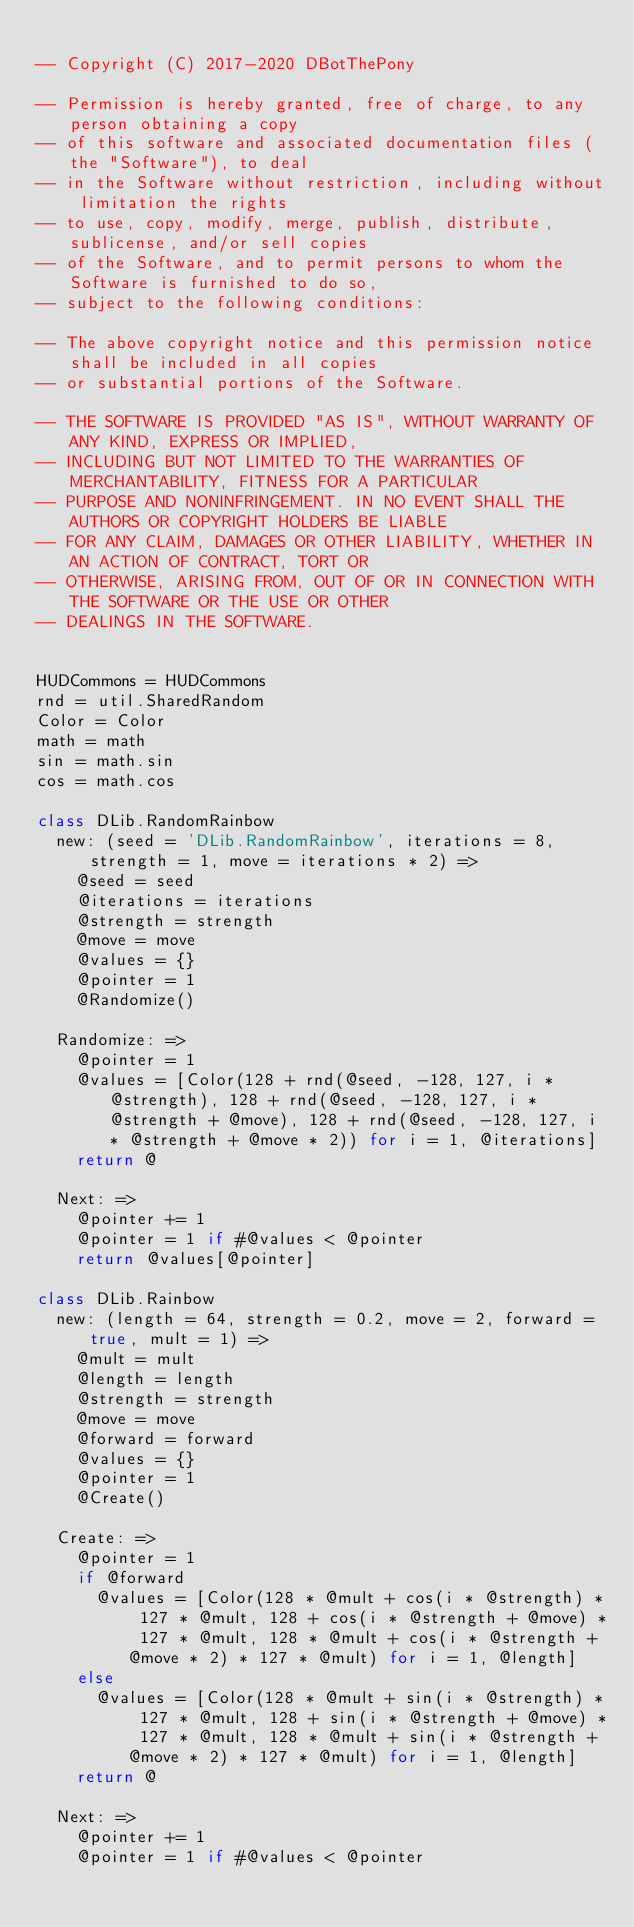<code> <loc_0><loc_0><loc_500><loc_500><_MoonScript_>
-- Copyright (C) 2017-2020 DBotThePony

-- Permission is hereby granted, free of charge, to any person obtaining a copy
-- of this software and associated documentation files (the "Software"), to deal
-- in the Software without restriction, including without limitation the rights
-- to use, copy, modify, merge, publish, distribute, sublicense, and/or sell copies
-- of the Software, and to permit persons to whom the Software is furnished to do so,
-- subject to the following conditions:

-- The above copyright notice and this permission notice shall be included in all copies
-- or substantial portions of the Software.

-- THE SOFTWARE IS PROVIDED "AS IS", WITHOUT WARRANTY OF ANY KIND, EXPRESS OR IMPLIED,
-- INCLUDING BUT NOT LIMITED TO THE WARRANTIES OF MERCHANTABILITY, FITNESS FOR A PARTICULAR
-- PURPOSE AND NONINFRINGEMENT. IN NO EVENT SHALL THE AUTHORS OR COPYRIGHT HOLDERS BE LIABLE
-- FOR ANY CLAIM, DAMAGES OR OTHER LIABILITY, WHETHER IN AN ACTION OF CONTRACT, TORT OR
-- OTHERWISE, ARISING FROM, OUT OF OR IN CONNECTION WITH THE SOFTWARE OR THE USE OR OTHER
-- DEALINGS IN THE SOFTWARE.


HUDCommons = HUDCommons
rnd = util.SharedRandom
Color = Color
math = math
sin = math.sin
cos = math.cos

class DLib.RandomRainbow
	new: (seed = 'DLib.RandomRainbow', iterations = 8, strength = 1, move = iterations * 2) =>
		@seed = seed
		@iterations = iterations
		@strength = strength
		@move = move
		@values = {}
		@pointer = 1
		@Randomize()

	Randomize: =>
		@pointer = 1
		@values = [Color(128 + rnd(@seed, -128, 127, i * @strength), 128 + rnd(@seed, -128, 127, i * @strength + @move), 128 + rnd(@seed, -128, 127, i * @strength + @move * 2)) for i = 1, @iterations]
		return @

	Next: =>
		@pointer += 1
		@pointer = 1 if #@values < @pointer
		return @values[@pointer]

class DLib.Rainbow
	new: (length = 64, strength = 0.2, move = 2, forward = true, mult = 1) =>
		@mult = mult
		@length = length
		@strength = strength
		@move = move
		@forward = forward
		@values = {}
		@pointer = 1
		@Create()

	Create: =>
		@pointer = 1
		if @forward
			@values = [Color(128 * @mult + cos(i * @strength) * 127 * @mult, 128 + cos(i * @strength + @move) * 127 * @mult, 128 * @mult + cos(i * @strength + @move * 2) * 127 * @mult) for i = 1, @length]
		else
			@values = [Color(128 * @mult + sin(i * @strength) * 127 * @mult, 128 + sin(i * @strength + @move) * 127 * @mult, 128 * @mult + sin(i * @strength + @move * 2) * 127 * @mult) for i = 1, @length]
		return @

	Next: =>
		@pointer += 1
		@pointer = 1 if #@values < @pointer</code> 